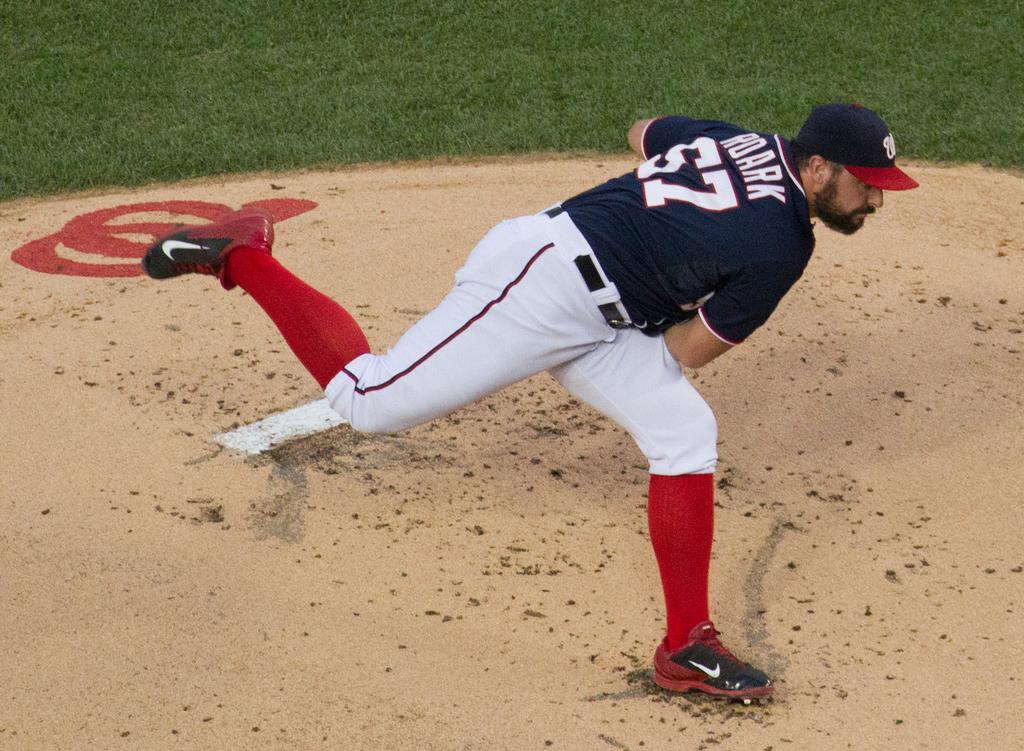<image>
Present a compact description of the photo's key features. A baseball player wearing number 57 is throwing a pitch towards home plate. 